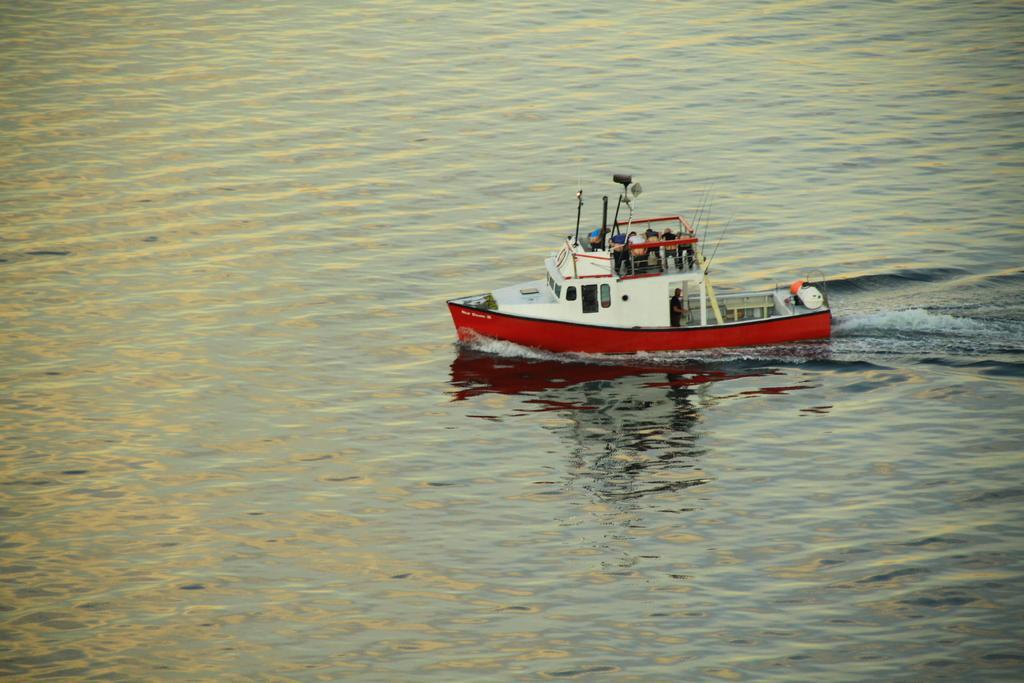How would you summarize this image in a sentence or two? There is a ship on the water on which few people are present. 